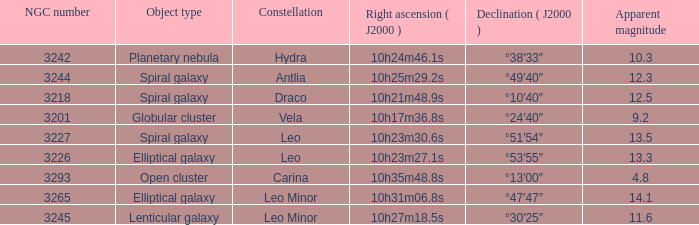What is the Apparent magnitude of a globular cluster? 9.2. 